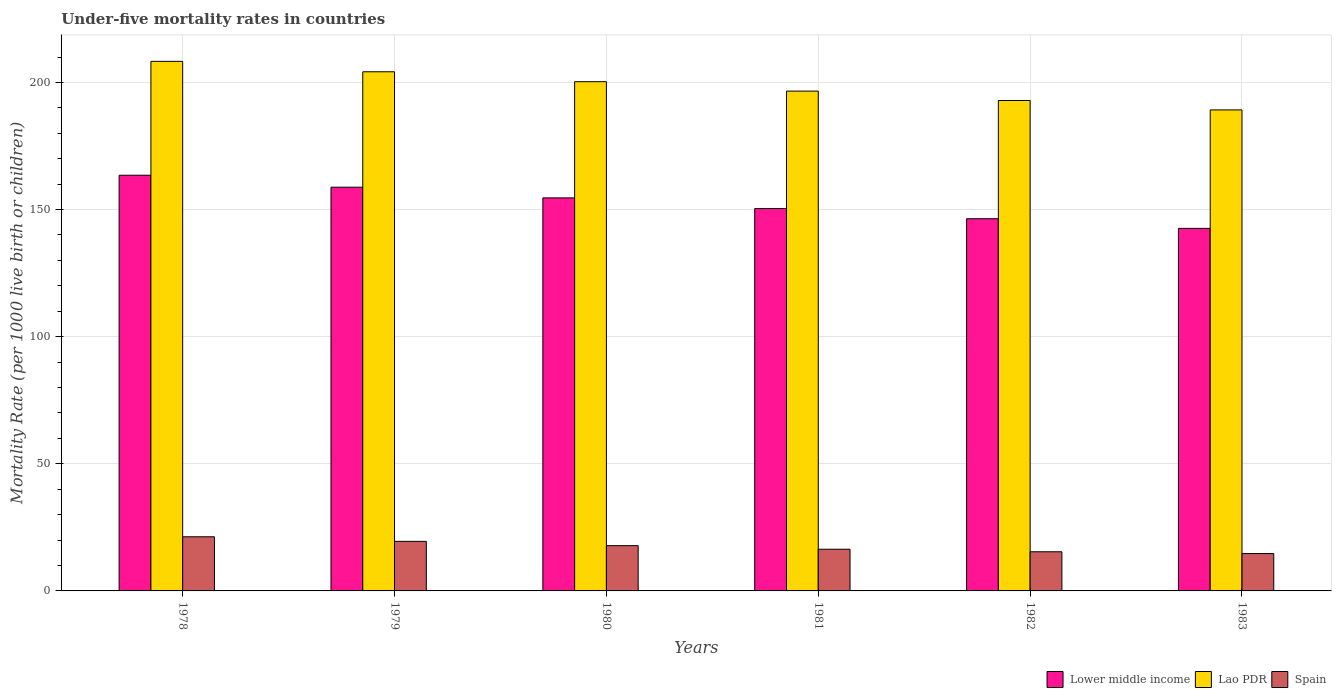How many different coloured bars are there?
Your answer should be compact. 3. How many groups of bars are there?
Your answer should be very brief. 6. How many bars are there on the 6th tick from the left?
Your answer should be very brief. 3. How many bars are there on the 2nd tick from the right?
Give a very brief answer. 3. What is the label of the 2nd group of bars from the left?
Offer a very short reply. 1979. What is the under-five mortality rate in Lower middle income in 1981?
Your response must be concise. 150.4. Across all years, what is the maximum under-five mortality rate in Lower middle income?
Your response must be concise. 163.5. Across all years, what is the minimum under-five mortality rate in Lao PDR?
Provide a short and direct response. 189.2. In which year was the under-five mortality rate in Lower middle income maximum?
Keep it short and to the point. 1978. What is the total under-five mortality rate in Lower middle income in the graph?
Your response must be concise. 916.3. What is the difference between the under-five mortality rate in Spain in 1982 and the under-five mortality rate in Lower middle income in 1980?
Keep it short and to the point. -139.2. What is the average under-five mortality rate in Lower middle income per year?
Make the answer very short. 152.72. In the year 1978, what is the difference between the under-five mortality rate in Lao PDR and under-five mortality rate in Spain?
Make the answer very short. 187. What is the ratio of the under-five mortality rate in Spain in 1979 to that in 1983?
Keep it short and to the point. 1.33. Is the under-five mortality rate in Spain in 1980 less than that in 1982?
Give a very brief answer. No. What is the difference between the highest and the second highest under-five mortality rate in Lao PDR?
Your response must be concise. 4.1. What is the difference between the highest and the lowest under-five mortality rate in Lao PDR?
Your answer should be very brief. 19.1. In how many years, is the under-five mortality rate in Lower middle income greater than the average under-five mortality rate in Lower middle income taken over all years?
Ensure brevity in your answer.  3. What does the 3rd bar from the left in 1983 represents?
Provide a short and direct response. Spain. Is it the case that in every year, the sum of the under-five mortality rate in Lower middle income and under-five mortality rate in Spain is greater than the under-five mortality rate in Lao PDR?
Ensure brevity in your answer.  No. Are all the bars in the graph horizontal?
Offer a very short reply. No. How many years are there in the graph?
Offer a terse response. 6. Are the values on the major ticks of Y-axis written in scientific E-notation?
Offer a very short reply. No. How are the legend labels stacked?
Your answer should be compact. Horizontal. What is the title of the graph?
Your response must be concise. Under-five mortality rates in countries. What is the label or title of the X-axis?
Give a very brief answer. Years. What is the label or title of the Y-axis?
Provide a succinct answer. Mortality Rate (per 1000 live birth or children). What is the Mortality Rate (per 1000 live birth or children) of Lower middle income in 1978?
Offer a terse response. 163.5. What is the Mortality Rate (per 1000 live birth or children) in Lao PDR in 1978?
Your answer should be compact. 208.3. What is the Mortality Rate (per 1000 live birth or children) of Spain in 1978?
Provide a succinct answer. 21.3. What is the Mortality Rate (per 1000 live birth or children) of Lower middle income in 1979?
Your answer should be compact. 158.8. What is the Mortality Rate (per 1000 live birth or children) of Lao PDR in 1979?
Your answer should be very brief. 204.2. What is the Mortality Rate (per 1000 live birth or children) in Spain in 1979?
Give a very brief answer. 19.5. What is the Mortality Rate (per 1000 live birth or children) in Lower middle income in 1980?
Give a very brief answer. 154.6. What is the Mortality Rate (per 1000 live birth or children) of Lao PDR in 1980?
Provide a succinct answer. 200.3. What is the Mortality Rate (per 1000 live birth or children) in Spain in 1980?
Provide a succinct answer. 17.8. What is the Mortality Rate (per 1000 live birth or children) of Lower middle income in 1981?
Offer a very short reply. 150.4. What is the Mortality Rate (per 1000 live birth or children) of Lao PDR in 1981?
Your answer should be compact. 196.6. What is the Mortality Rate (per 1000 live birth or children) in Spain in 1981?
Your response must be concise. 16.4. What is the Mortality Rate (per 1000 live birth or children) in Lower middle income in 1982?
Keep it short and to the point. 146.4. What is the Mortality Rate (per 1000 live birth or children) in Lao PDR in 1982?
Give a very brief answer. 192.9. What is the Mortality Rate (per 1000 live birth or children) in Lower middle income in 1983?
Provide a succinct answer. 142.6. What is the Mortality Rate (per 1000 live birth or children) in Lao PDR in 1983?
Offer a very short reply. 189.2. Across all years, what is the maximum Mortality Rate (per 1000 live birth or children) of Lower middle income?
Offer a terse response. 163.5. Across all years, what is the maximum Mortality Rate (per 1000 live birth or children) in Lao PDR?
Your answer should be very brief. 208.3. Across all years, what is the maximum Mortality Rate (per 1000 live birth or children) of Spain?
Make the answer very short. 21.3. Across all years, what is the minimum Mortality Rate (per 1000 live birth or children) in Lower middle income?
Make the answer very short. 142.6. Across all years, what is the minimum Mortality Rate (per 1000 live birth or children) in Lao PDR?
Provide a succinct answer. 189.2. What is the total Mortality Rate (per 1000 live birth or children) in Lower middle income in the graph?
Provide a succinct answer. 916.3. What is the total Mortality Rate (per 1000 live birth or children) of Lao PDR in the graph?
Your answer should be compact. 1191.5. What is the total Mortality Rate (per 1000 live birth or children) in Spain in the graph?
Keep it short and to the point. 105.1. What is the difference between the Mortality Rate (per 1000 live birth or children) of Lao PDR in 1978 and that in 1979?
Provide a succinct answer. 4.1. What is the difference between the Mortality Rate (per 1000 live birth or children) of Spain in 1978 and that in 1979?
Give a very brief answer. 1.8. What is the difference between the Mortality Rate (per 1000 live birth or children) in Spain in 1978 and that in 1980?
Make the answer very short. 3.5. What is the difference between the Mortality Rate (per 1000 live birth or children) of Lower middle income in 1978 and that in 1981?
Offer a very short reply. 13.1. What is the difference between the Mortality Rate (per 1000 live birth or children) in Spain in 1978 and that in 1981?
Make the answer very short. 4.9. What is the difference between the Mortality Rate (per 1000 live birth or children) of Lower middle income in 1978 and that in 1982?
Offer a very short reply. 17.1. What is the difference between the Mortality Rate (per 1000 live birth or children) in Lower middle income in 1978 and that in 1983?
Offer a very short reply. 20.9. What is the difference between the Mortality Rate (per 1000 live birth or children) in Lao PDR in 1978 and that in 1983?
Give a very brief answer. 19.1. What is the difference between the Mortality Rate (per 1000 live birth or children) of Lower middle income in 1979 and that in 1980?
Provide a short and direct response. 4.2. What is the difference between the Mortality Rate (per 1000 live birth or children) in Spain in 1979 and that in 1980?
Give a very brief answer. 1.7. What is the difference between the Mortality Rate (per 1000 live birth or children) of Lower middle income in 1979 and that in 1981?
Provide a succinct answer. 8.4. What is the difference between the Mortality Rate (per 1000 live birth or children) in Lao PDR in 1979 and that in 1981?
Make the answer very short. 7.6. What is the difference between the Mortality Rate (per 1000 live birth or children) in Spain in 1979 and that in 1981?
Make the answer very short. 3.1. What is the difference between the Mortality Rate (per 1000 live birth or children) in Lao PDR in 1979 and that in 1982?
Provide a short and direct response. 11.3. What is the difference between the Mortality Rate (per 1000 live birth or children) in Spain in 1979 and that in 1982?
Provide a short and direct response. 4.1. What is the difference between the Mortality Rate (per 1000 live birth or children) in Lower middle income in 1979 and that in 1983?
Your answer should be compact. 16.2. What is the difference between the Mortality Rate (per 1000 live birth or children) of Lower middle income in 1980 and that in 1981?
Make the answer very short. 4.2. What is the difference between the Mortality Rate (per 1000 live birth or children) in Lower middle income in 1980 and that in 1982?
Your response must be concise. 8.2. What is the difference between the Mortality Rate (per 1000 live birth or children) of Lao PDR in 1980 and that in 1982?
Provide a short and direct response. 7.4. What is the difference between the Mortality Rate (per 1000 live birth or children) of Spain in 1980 and that in 1983?
Ensure brevity in your answer.  3.1. What is the difference between the Mortality Rate (per 1000 live birth or children) of Lao PDR in 1981 and that in 1982?
Ensure brevity in your answer.  3.7. What is the difference between the Mortality Rate (per 1000 live birth or children) in Lower middle income in 1981 and that in 1983?
Offer a terse response. 7.8. What is the difference between the Mortality Rate (per 1000 live birth or children) in Lao PDR in 1981 and that in 1983?
Your answer should be very brief. 7.4. What is the difference between the Mortality Rate (per 1000 live birth or children) in Lower middle income in 1982 and that in 1983?
Your answer should be very brief. 3.8. What is the difference between the Mortality Rate (per 1000 live birth or children) of Spain in 1982 and that in 1983?
Provide a succinct answer. 0.7. What is the difference between the Mortality Rate (per 1000 live birth or children) of Lower middle income in 1978 and the Mortality Rate (per 1000 live birth or children) of Lao PDR in 1979?
Give a very brief answer. -40.7. What is the difference between the Mortality Rate (per 1000 live birth or children) in Lower middle income in 1978 and the Mortality Rate (per 1000 live birth or children) in Spain in 1979?
Ensure brevity in your answer.  144. What is the difference between the Mortality Rate (per 1000 live birth or children) in Lao PDR in 1978 and the Mortality Rate (per 1000 live birth or children) in Spain in 1979?
Your answer should be very brief. 188.8. What is the difference between the Mortality Rate (per 1000 live birth or children) in Lower middle income in 1978 and the Mortality Rate (per 1000 live birth or children) in Lao PDR in 1980?
Your answer should be compact. -36.8. What is the difference between the Mortality Rate (per 1000 live birth or children) of Lower middle income in 1978 and the Mortality Rate (per 1000 live birth or children) of Spain in 1980?
Keep it short and to the point. 145.7. What is the difference between the Mortality Rate (per 1000 live birth or children) in Lao PDR in 1978 and the Mortality Rate (per 1000 live birth or children) in Spain in 1980?
Make the answer very short. 190.5. What is the difference between the Mortality Rate (per 1000 live birth or children) in Lower middle income in 1978 and the Mortality Rate (per 1000 live birth or children) in Lao PDR in 1981?
Make the answer very short. -33.1. What is the difference between the Mortality Rate (per 1000 live birth or children) of Lower middle income in 1978 and the Mortality Rate (per 1000 live birth or children) of Spain in 1981?
Offer a terse response. 147.1. What is the difference between the Mortality Rate (per 1000 live birth or children) of Lao PDR in 1978 and the Mortality Rate (per 1000 live birth or children) of Spain in 1981?
Your answer should be very brief. 191.9. What is the difference between the Mortality Rate (per 1000 live birth or children) in Lower middle income in 1978 and the Mortality Rate (per 1000 live birth or children) in Lao PDR in 1982?
Your answer should be very brief. -29.4. What is the difference between the Mortality Rate (per 1000 live birth or children) in Lower middle income in 1978 and the Mortality Rate (per 1000 live birth or children) in Spain in 1982?
Your response must be concise. 148.1. What is the difference between the Mortality Rate (per 1000 live birth or children) in Lao PDR in 1978 and the Mortality Rate (per 1000 live birth or children) in Spain in 1982?
Give a very brief answer. 192.9. What is the difference between the Mortality Rate (per 1000 live birth or children) of Lower middle income in 1978 and the Mortality Rate (per 1000 live birth or children) of Lao PDR in 1983?
Offer a very short reply. -25.7. What is the difference between the Mortality Rate (per 1000 live birth or children) of Lower middle income in 1978 and the Mortality Rate (per 1000 live birth or children) of Spain in 1983?
Keep it short and to the point. 148.8. What is the difference between the Mortality Rate (per 1000 live birth or children) in Lao PDR in 1978 and the Mortality Rate (per 1000 live birth or children) in Spain in 1983?
Give a very brief answer. 193.6. What is the difference between the Mortality Rate (per 1000 live birth or children) in Lower middle income in 1979 and the Mortality Rate (per 1000 live birth or children) in Lao PDR in 1980?
Make the answer very short. -41.5. What is the difference between the Mortality Rate (per 1000 live birth or children) in Lower middle income in 1979 and the Mortality Rate (per 1000 live birth or children) in Spain in 1980?
Your answer should be compact. 141. What is the difference between the Mortality Rate (per 1000 live birth or children) in Lao PDR in 1979 and the Mortality Rate (per 1000 live birth or children) in Spain in 1980?
Ensure brevity in your answer.  186.4. What is the difference between the Mortality Rate (per 1000 live birth or children) in Lower middle income in 1979 and the Mortality Rate (per 1000 live birth or children) in Lao PDR in 1981?
Your response must be concise. -37.8. What is the difference between the Mortality Rate (per 1000 live birth or children) of Lower middle income in 1979 and the Mortality Rate (per 1000 live birth or children) of Spain in 1981?
Your answer should be compact. 142.4. What is the difference between the Mortality Rate (per 1000 live birth or children) in Lao PDR in 1979 and the Mortality Rate (per 1000 live birth or children) in Spain in 1981?
Offer a terse response. 187.8. What is the difference between the Mortality Rate (per 1000 live birth or children) of Lower middle income in 1979 and the Mortality Rate (per 1000 live birth or children) of Lao PDR in 1982?
Your answer should be very brief. -34.1. What is the difference between the Mortality Rate (per 1000 live birth or children) in Lower middle income in 1979 and the Mortality Rate (per 1000 live birth or children) in Spain in 1982?
Make the answer very short. 143.4. What is the difference between the Mortality Rate (per 1000 live birth or children) of Lao PDR in 1979 and the Mortality Rate (per 1000 live birth or children) of Spain in 1982?
Your response must be concise. 188.8. What is the difference between the Mortality Rate (per 1000 live birth or children) in Lower middle income in 1979 and the Mortality Rate (per 1000 live birth or children) in Lao PDR in 1983?
Your answer should be compact. -30.4. What is the difference between the Mortality Rate (per 1000 live birth or children) in Lower middle income in 1979 and the Mortality Rate (per 1000 live birth or children) in Spain in 1983?
Your answer should be very brief. 144.1. What is the difference between the Mortality Rate (per 1000 live birth or children) in Lao PDR in 1979 and the Mortality Rate (per 1000 live birth or children) in Spain in 1983?
Offer a very short reply. 189.5. What is the difference between the Mortality Rate (per 1000 live birth or children) of Lower middle income in 1980 and the Mortality Rate (per 1000 live birth or children) of Lao PDR in 1981?
Your response must be concise. -42. What is the difference between the Mortality Rate (per 1000 live birth or children) of Lower middle income in 1980 and the Mortality Rate (per 1000 live birth or children) of Spain in 1981?
Offer a very short reply. 138.2. What is the difference between the Mortality Rate (per 1000 live birth or children) of Lao PDR in 1980 and the Mortality Rate (per 1000 live birth or children) of Spain in 1981?
Your answer should be very brief. 183.9. What is the difference between the Mortality Rate (per 1000 live birth or children) of Lower middle income in 1980 and the Mortality Rate (per 1000 live birth or children) of Lao PDR in 1982?
Provide a succinct answer. -38.3. What is the difference between the Mortality Rate (per 1000 live birth or children) in Lower middle income in 1980 and the Mortality Rate (per 1000 live birth or children) in Spain in 1982?
Make the answer very short. 139.2. What is the difference between the Mortality Rate (per 1000 live birth or children) of Lao PDR in 1980 and the Mortality Rate (per 1000 live birth or children) of Spain in 1982?
Provide a succinct answer. 184.9. What is the difference between the Mortality Rate (per 1000 live birth or children) in Lower middle income in 1980 and the Mortality Rate (per 1000 live birth or children) in Lao PDR in 1983?
Provide a short and direct response. -34.6. What is the difference between the Mortality Rate (per 1000 live birth or children) of Lower middle income in 1980 and the Mortality Rate (per 1000 live birth or children) of Spain in 1983?
Your answer should be compact. 139.9. What is the difference between the Mortality Rate (per 1000 live birth or children) in Lao PDR in 1980 and the Mortality Rate (per 1000 live birth or children) in Spain in 1983?
Provide a short and direct response. 185.6. What is the difference between the Mortality Rate (per 1000 live birth or children) of Lower middle income in 1981 and the Mortality Rate (per 1000 live birth or children) of Lao PDR in 1982?
Your answer should be compact. -42.5. What is the difference between the Mortality Rate (per 1000 live birth or children) of Lower middle income in 1981 and the Mortality Rate (per 1000 live birth or children) of Spain in 1982?
Give a very brief answer. 135. What is the difference between the Mortality Rate (per 1000 live birth or children) in Lao PDR in 1981 and the Mortality Rate (per 1000 live birth or children) in Spain in 1982?
Your answer should be compact. 181.2. What is the difference between the Mortality Rate (per 1000 live birth or children) in Lower middle income in 1981 and the Mortality Rate (per 1000 live birth or children) in Lao PDR in 1983?
Offer a terse response. -38.8. What is the difference between the Mortality Rate (per 1000 live birth or children) of Lower middle income in 1981 and the Mortality Rate (per 1000 live birth or children) of Spain in 1983?
Keep it short and to the point. 135.7. What is the difference between the Mortality Rate (per 1000 live birth or children) in Lao PDR in 1981 and the Mortality Rate (per 1000 live birth or children) in Spain in 1983?
Keep it short and to the point. 181.9. What is the difference between the Mortality Rate (per 1000 live birth or children) in Lower middle income in 1982 and the Mortality Rate (per 1000 live birth or children) in Lao PDR in 1983?
Your answer should be very brief. -42.8. What is the difference between the Mortality Rate (per 1000 live birth or children) of Lower middle income in 1982 and the Mortality Rate (per 1000 live birth or children) of Spain in 1983?
Keep it short and to the point. 131.7. What is the difference between the Mortality Rate (per 1000 live birth or children) in Lao PDR in 1982 and the Mortality Rate (per 1000 live birth or children) in Spain in 1983?
Give a very brief answer. 178.2. What is the average Mortality Rate (per 1000 live birth or children) of Lower middle income per year?
Keep it short and to the point. 152.72. What is the average Mortality Rate (per 1000 live birth or children) in Lao PDR per year?
Ensure brevity in your answer.  198.58. What is the average Mortality Rate (per 1000 live birth or children) in Spain per year?
Keep it short and to the point. 17.52. In the year 1978, what is the difference between the Mortality Rate (per 1000 live birth or children) in Lower middle income and Mortality Rate (per 1000 live birth or children) in Lao PDR?
Your answer should be very brief. -44.8. In the year 1978, what is the difference between the Mortality Rate (per 1000 live birth or children) of Lower middle income and Mortality Rate (per 1000 live birth or children) of Spain?
Your answer should be compact. 142.2. In the year 1978, what is the difference between the Mortality Rate (per 1000 live birth or children) in Lao PDR and Mortality Rate (per 1000 live birth or children) in Spain?
Your answer should be very brief. 187. In the year 1979, what is the difference between the Mortality Rate (per 1000 live birth or children) of Lower middle income and Mortality Rate (per 1000 live birth or children) of Lao PDR?
Keep it short and to the point. -45.4. In the year 1979, what is the difference between the Mortality Rate (per 1000 live birth or children) of Lower middle income and Mortality Rate (per 1000 live birth or children) of Spain?
Your answer should be compact. 139.3. In the year 1979, what is the difference between the Mortality Rate (per 1000 live birth or children) of Lao PDR and Mortality Rate (per 1000 live birth or children) of Spain?
Provide a succinct answer. 184.7. In the year 1980, what is the difference between the Mortality Rate (per 1000 live birth or children) in Lower middle income and Mortality Rate (per 1000 live birth or children) in Lao PDR?
Give a very brief answer. -45.7. In the year 1980, what is the difference between the Mortality Rate (per 1000 live birth or children) in Lower middle income and Mortality Rate (per 1000 live birth or children) in Spain?
Give a very brief answer. 136.8. In the year 1980, what is the difference between the Mortality Rate (per 1000 live birth or children) in Lao PDR and Mortality Rate (per 1000 live birth or children) in Spain?
Offer a very short reply. 182.5. In the year 1981, what is the difference between the Mortality Rate (per 1000 live birth or children) in Lower middle income and Mortality Rate (per 1000 live birth or children) in Lao PDR?
Offer a terse response. -46.2. In the year 1981, what is the difference between the Mortality Rate (per 1000 live birth or children) in Lower middle income and Mortality Rate (per 1000 live birth or children) in Spain?
Make the answer very short. 134. In the year 1981, what is the difference between the Mortality Rate (per 1000 live birth or children) in Lao PDR and Mortality Rate (per 1000 live birth or children) in Spain?
Offer a very short reply. 180.2. In the year 1982, what is the difference between the Mortality Rate (per 1000 live birth or children) of Lower middle income and Mortality Rate (per 1000 live birth or children) of Lao PDR?
Your answer should be very brief. -46.5. In the year 1982, what is the difference between the Mortality Rate (per 1000 live birth or children) in Lower middle income and Mortality Rate (per 1000 live birth or children) in Spain?
Your answer should be compact. 131. In the year 1982, what is the difference between the Mortality Rate (per 1000 live birth or children) of Lao PDR and Mortality Rate (per 1000 live birth or children) of Spain?
Make the answer very short. 177.5. In the year 1983, what is the difference between the Mortality Rate (per 1000 live birth or children) of Lower middle income and Mortality Rate (per 1000 live birth or children) of Lao PDR?
Keep it short and to the point. -46.6. In the year 1983, what is the difference between the Mortality Rate (per 1000 live birth or children) of Lower middle income and Mortality Rate (per 1000 live birth or children) of Spain?
Make the answer very short. 127.9. In the year 1983, what is the difference between the Mortality Rate (per 1000 live birth or children) in Lao PDR and Mortality Rate (per 1000 live birth or children) in Spain?
Provide a succinct answer. 174.5. What is the ratio of the Mortality Rate (per 1000 live birth or children) of Lower middle income in 1978 to that in 1979?
Offer a very short reply. 1.03. What is the ratio of the Mortality Rate (per 1000 live birth or children) in Lao PDR in 1978 to that in 1979?
Offer a terse response. 1.02. What is the ratio of the Mortality Rate (per 1000 live birth or children) of Spain in 1978 to that in 1979?
Give a very brief answer. 1.09. What is the ratio of the Mortality Rate (per 1000 live birth or children) in Lower middle income in 1978 to that in 1980?
Your response must be concise. 1.06. What is the ratio of the Mortality Rate (per 1000 live birth or children) in Lao PDR in 1978 to that in 1980?
Give a very brief answer. 1.04. What is the ratio of the Mortality Rate (per 1000 live birth or children) of Spain in 1978 to that in 1980?
Keep it short and to the point. 1.2. What is the ratio of the Mortality Rate (per 1000 live birth or children) of Lower middle income in 1978 to that in 1981?
Provide a succinct answer. 1.09. What is the ratio of the Mortality Rate (per 1000 live birth or children) in Lao PDR in 1978 to that in 1981?
Your answer should be compact. 1.06. What is the ratio of the Mortality Rate (per 1000 live birth or children) of Spain in 1978 to that in 1981?
Your response must be concise. 1.3. What is the ratio of the Mortality Rate (per 1000 live birth or children) in Lower middle income in 1978 to that in 1982?
Your response must be concise. 1.12. What is the ratio of the Mortality Rate (per 1000 live birth or children) in Lao PDR in 1978 to that in 1982?
Your response must be concise. 1.08. What is the ratio of the Mortality Rate (per 1000 live birth or children) of Spain in 1978 to that in 1982?
Offer a very short reply. 1.38. What is the ratio of the Mortality Rate (per 1000 live birth or children) in Lower middle income in 1978 to that in 1983?
Give a very brief answer. 1.15. What is the ratio of the Mortality Rate (per 1000 live birth or children) in Lao PDR in 1978 to that in 1983?
Offer a terse response. 1.1. What is the ratio of the Mortality Rate (per 1000 live birth or children) of Spain in 1978 to that in 1983?
Your answer should be compact. 1.45. What is the ratio of the Mortality Rate (per 1000 live birth or children) of Lower middle income in 1979 to that in 1980?
Offer a terse response. 1.03. What is the ratio of the Mortality Rate (per 1000 live birth or children) in Lao PDR in 1979 to that in 1980?
Keep it short and to the point. 1.02. What is the ratio of the Mortality Rate (per 1000 live birth or children) of Spain in 1979 to that in 1980?
Your answer should be very brief. 1.1. What is the ratio of the Mortality Rate (per 1000 live birth or children) of Lower middle income in 1979 to that in 1981?
Give a very brief answer. 1.06. What is the ratio of the Mortality Rate (per 1000 live birth or children) in Lao PDR in 1979 to that in 1981?
Ensure brevity in your answer.  1.04. What is the ratio of the Mortality Rate (per 1000 live birth or children) of Spain in 1979 to that in 1981?
Keep it short and to the point. 1.19. What is the ratio of the Mortality Rate (per 1000 live birth or children) of Lower middle income in 1979 to that in 1982?
Keep it short and to the point. 1.08. What is the ratio of the Mortality Rate (per 1000 live birth or children) in Lao PDR in 1979 to that in 1982?
Your answer should be very brief. 1.06. What is the ratio of the Mortality Rate (per 1000 live birth or children) of Spain in 1979 to that in 1982?
Ensure brevity in your answer.  1.27. What is the ratio of the Mortality Rate (per 1000 live birth or children) of Lower middle income in 1979 to that in 1983?
Provide a short and direct response. 1.11. What is the ratio of the Mortality Rate (per 1000 live birth or children) in Lao PDR in 1979 to that in 1983?
Offer a terse response. 1.08. What is the ratio of the Mortality Rate (per 1000 live birth or children) in Spain in 1979 to that in 1983?
Give a very brief answer. 1.33. What is the ratio of the Mortality Rate (per 1000 live birth or children) in Lower middle income in 1980 to that in 1981?
Provide a succinct answer. 1.03. What is the ratio of the Mortality Rate (per 1000 live birth or children) of Lao PDR in 1980 to that in 1981?
Provide a succinct answer. 1.02. What is the ratio of the Mortality Rate (per 1000 live birth or children) of Spain in 1980 to that in 1981?
Your answer should be very brief. 1.09. What is the ratio of the Mortality Rate (per 1000 live birth or children) in Lower middle income in 1980 to that in 1982?
Offer a terse response. 1.06. What is the ratio of the Mortality Rate (per 1000 live birth or children) in Lao PDR in 1980 to that in 1982?
Make the answer very short. 1.04. What is the ratio of the Mortality Rate (per 1000 live birth or children) of Spain in 1980 to that in 1982?
Your answer should be compact. 1.16. What is the ratio of the Mortality Rate (per 1000 live birth or children) of Lower middle income in 1980 to that in 1983?
Offer a terse response. 1.08. What is the ratio of the Mortality Rate (per 1000 live birth or children) of Lao PDR in 1980 to that in 1983?
Offer a terse response. 1.06. What is the ratio of the Mortality Rate (per 1000 live birth or children) in Spain in 1980 to that in 1983?
Your response must be concise. 1.21. What is the ratio of the Mortality Rate (per 1000 live birth or children) in Lower middle income in 1981 to that in 1982?
Give a very brief answer. 1.03. What is the ratio of the Mortality Rate (per 1000 live birth or children) in Lao PDR in 1981 to that in 1982?
Give a very brief answer. 1.02. What is the ratio of the Mortality Rate (per 1000 live birth or children) of Spain in 1981 to that in 1982?
Offer a very short reply. 1.06. What is the ratio of the Mortality Rate (per 1000 live birth or children) in Lower middle income in 1981 to that in 1983?
Provide a short and direct response. 1.05. What is the ratio of the Mortality Rate (per 1000 live birth or children) of Lao PDR in 1981 to that in 1983?
Your answer should be very brief. 1.04. What is the ratio of the Mortality Rate (per 1000 live birth or children) in Spain in 1981 to that in 1983?
Offer a terse response. 1.12. What is the ratio of the Mortality Rate (per 1000 live birth or children) of Lower middle income in 1982 to that in 1983?
Ensure brevity in your answer.  1.03. What is the ratio of the Mortality Rate (per 1000 live birth or children) of Lao PDR in 1982 to that in 1983?
Make the answer very short. 1.02. What is the ratio of the Mortality Rate (per 1000 live birth or children) of Spain in 1982 to that in 1983?
Make the answer very short. 1.05. What is the difference between the highest and the second highest Mortality Rate (per 1000 live birth or children) of Lower middle income?
Offer a very short reply. 4.7. What is the difference between the highest and the lowest Mortality Rate (per 1000 live birth or children) in Lower middle income?
Your answer should be compact. 20.9. What is the difference between the highest and the lowest Mortality Rate (per 1000 live birth or children) in Lao PDR?
Make the answer very short. 19.1. What is the difference between the highest and the lowest Mortality Rate (per 1000 live birth or children) of Spain?
Give a very brief answer. 6.6. 